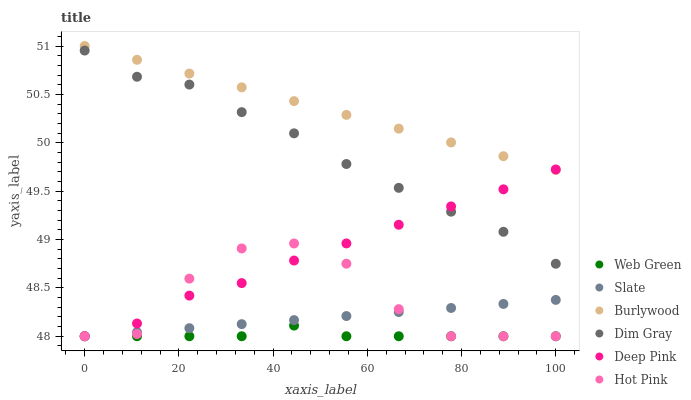Does Web Green have the minimum area under the curve?
Answer yes or no. Yes. Does Burlywood have the maximum area under the curve?
Answer yes or no. Yes. Does Slate have the minimum area under the curve?
Answer yes or no. No. Does Slate have the maximum area under the curve?
Answer yes or no. No. Is Slate the smoothest?
Answer yes or no. Yes. Is Hot Pink the roughest?
Answer yes or no. Yes. Is Burlywood the smoothest?
Answer yes or no. No. Is Burlywood the roughest?
Answer yes or no. No. Does Slate have the lowest value?
Answer yes or no. Yes. Does Burlywood have the lowest value?
Answer yes or no. No. Does Burlywood have the highest value?
Answer yes or no. Yes. Does Slate have the highest value?
Answer yes or no. No. Is Dim Gray less than Burlywood?
Answer yes or no. Yes. Is Burlywood greater than Hot Pink?
Answer yes or no. Yes. Does Hot Pink intersect Slate?
Answer yes or no. Yes. Is Hot Pink less than Slate?
Answer yes or no. No. Is Hot Pink greater than Slate?
Answer yes or no. No. Does Dim Gray intersect Burlywood?
Answer yes or no. No. 